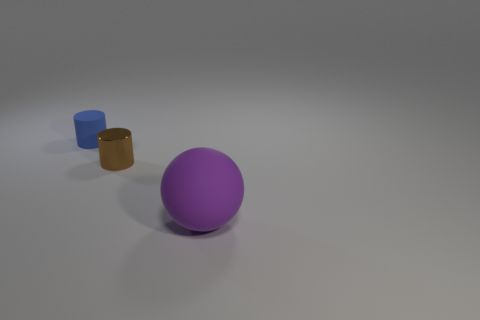There is a object right of the brown cylinder; what is its size?
Provide a succinct answer. Large. How many blue matte things have the same shape as the purple matte thing?
Your response must be concise. 0. There is a large object that is made of the same material as the tiny blue object; what is its shape?
Your response must be concise. Sphere. How many brown objects are metallic objects or shiny spheres?
Your response must be concise. 1. Are there any large purple balls right of the tiny metallic object?
Your response must be concise. Yes. Does the object behind the brown cylinder have the same shape as the small shiny object that is in front of the tiny matte thing?
Keep it short and to the point. Yes. There is a small brown object that is the same shape as the blue matte thing; what is it made of?
Give a very brief answer. Metal. How many cylinders are gray rubber things or small objects?
Make the answer very short. 2. What number of blue cylinders are made of the same material as the sphere?
Your response must be concise. 1. Is the material of the thing behind the shiny object the same as the tiny thing to the right of the rubber cylinder?
Make the answer very short. No. 